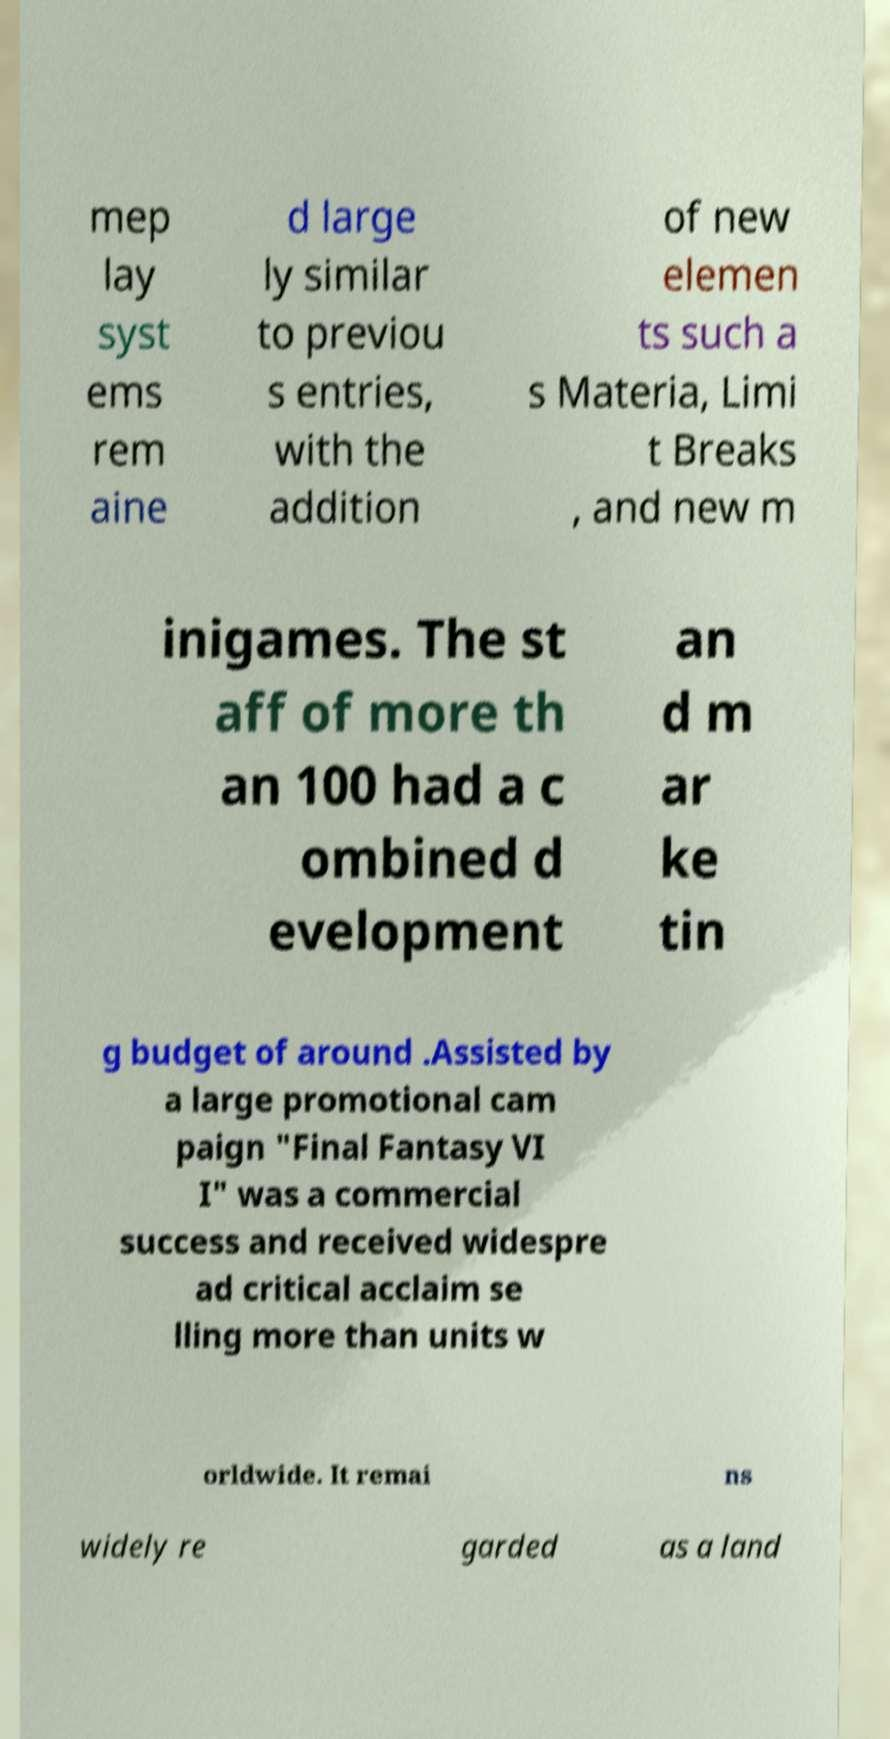Please identify and transcribe the text found in this image. mep lay syst ems rem aine d large ly similar to previou s entries, with the addition of new elemen ts such a s Materia, Limi t Breaks , and new m inigames. The st aff of more th an 100 had a c ombined d evelopment an d m ar ke tin g budget of around .Assisted by a large promotional cam paign "Final Fantasy VI I" was a commercial success and received widespre ad critical acclaim se lling more than units w orldwide. It remai ns widely re garded as a land 